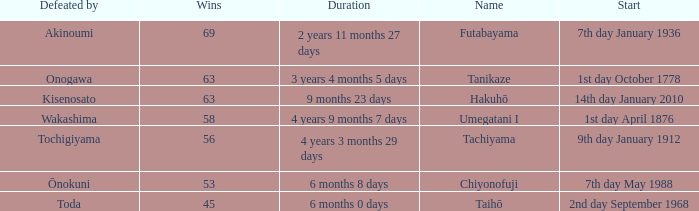What is the Duration for less than 53 consecutive wins? 6 months 0 days. 